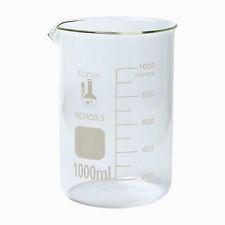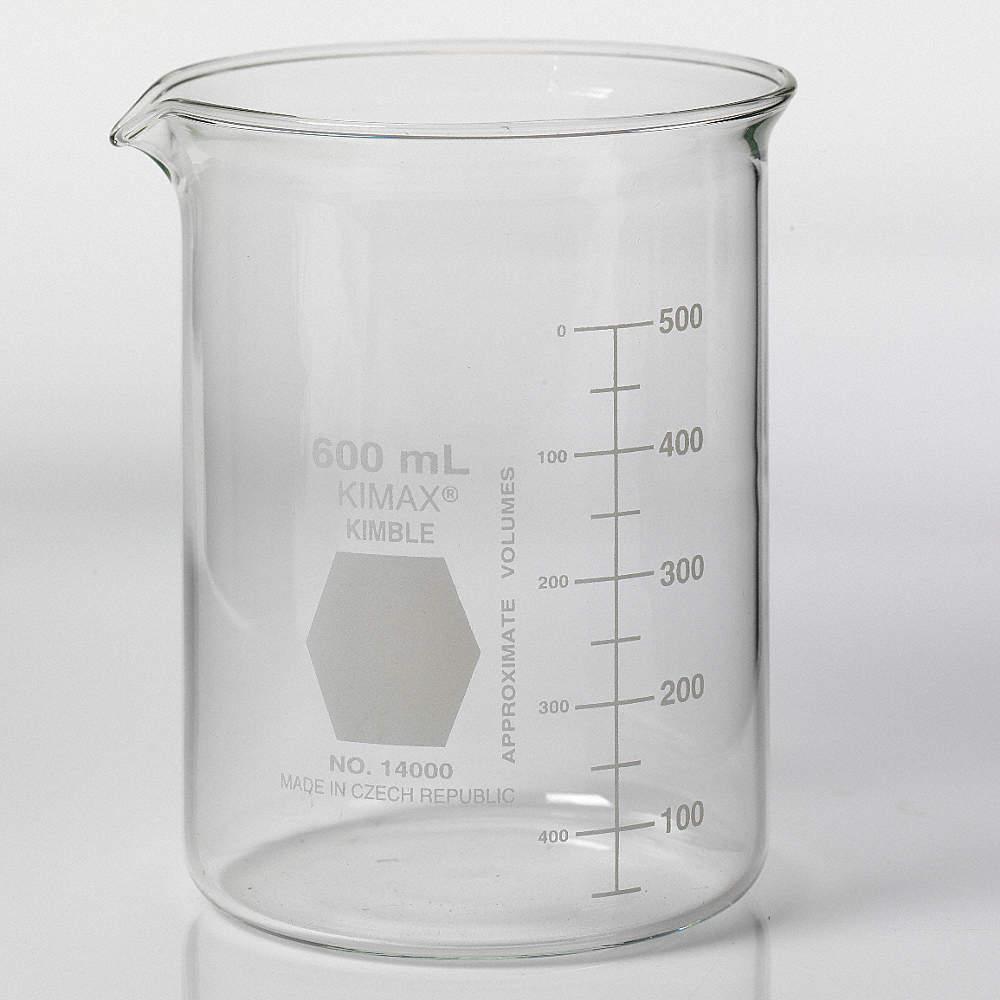The first image is the image on the left, the second image is the image on the right. Given the left and right images, does the statement "There are two beakers facing left with one hexagon and one square printed on the beaker." hold true? Answer yes or no. Yes. The first image is the image on the left, the second image is the image on the right. Examine the images to the left and right. Is the description "One beaker has a gray hexagon shape next to its volume line, and the other beaker has a square shape." accurate? Answer yes or no. Yes. 